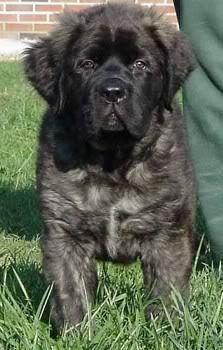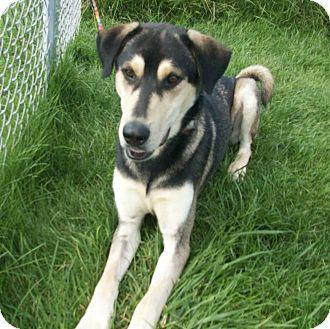The first image is the image on the left, the second image is the image on the right. For the images shown, is this caption "A man is standing behind a big husky dog, who is standing with his face forward and his tongue hanging." true? Answer yes or no. No. 